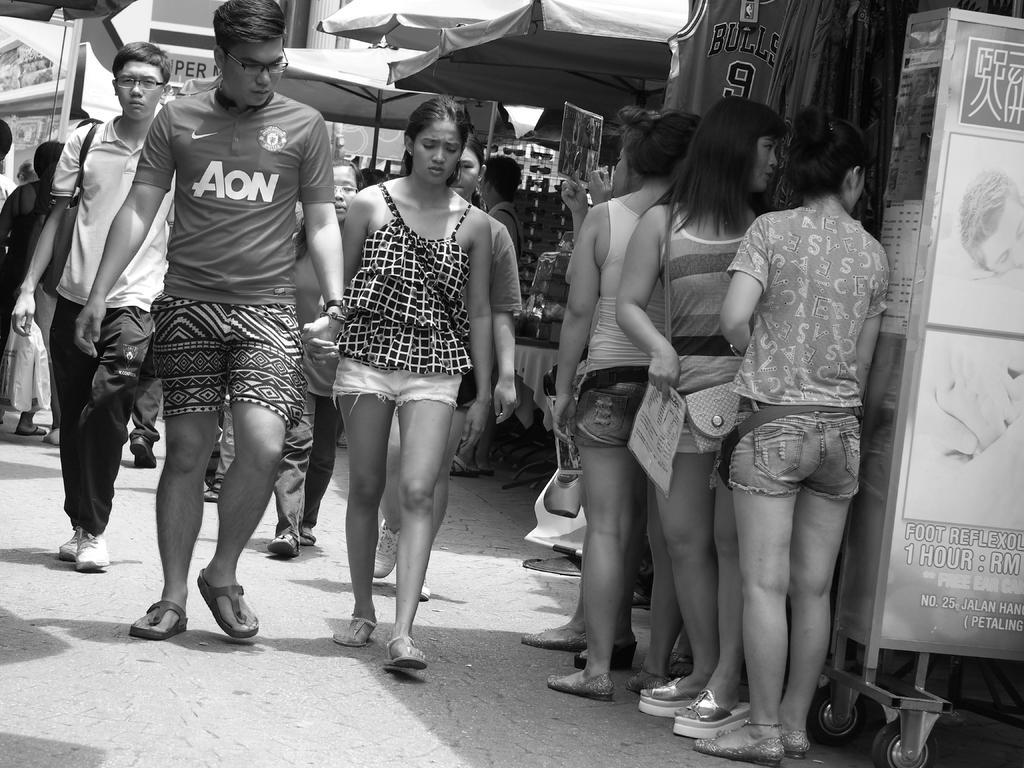Describe this image in one or two sentences. This is a black and white picture. In the middle of the picture, we see people are walking on the road. on the right side, we see the stall and people are standing beside that. We see the people standing under the tents. We even see stalls in the background. This picture is clicked outside the city. 